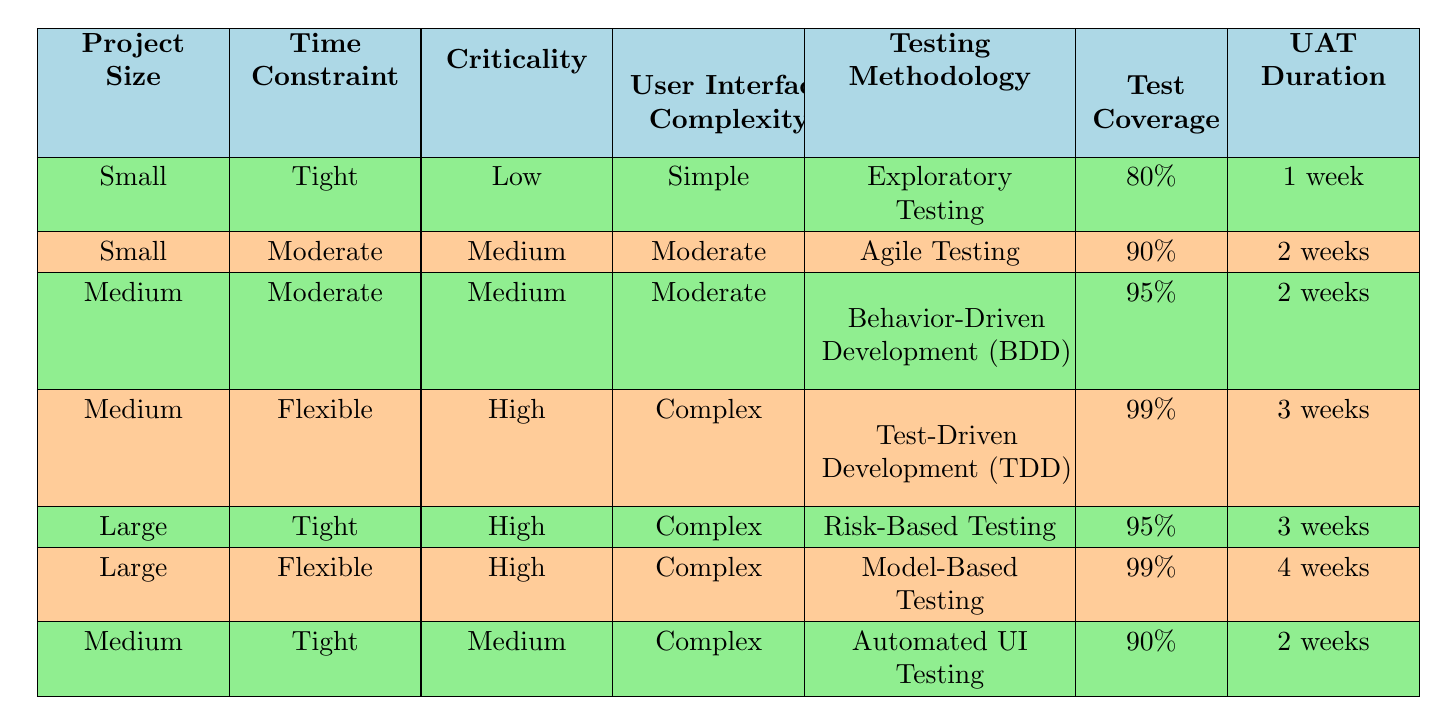What testing methodology is recommended for a small project with tight time constraints and low criticality? To find the answer, look for the row where Project Size is "Small", Time Constraint is "Tight", and Criticality is "Low". In the table, this matches the actions: "Exploratory Testing".
Answer: Exploratory Testing What is the test coverage for a medium project that has a moderate time constraint and medium criticality? Identify the row with Project Size as "Medium", Time Constraint as "Moderate", and Criticality as "Medium". This reveals the Test Coverage value listed as "95%".
Answer: 95% Are user acceptance testing durations consistent across all project types? Check each row in the table for User Acceptance Testing Duration. "1 week", "2 weeks", "3 weeks", and "4 weeks" are all present, indicating varying durations based on project types rather than consistency.
Answer: No What is the maximum test coverage achievable for projects with high criticality? Examine the rows where Criticality is "High". The maximum test coverage in these rows is "99%", which corresponds to both the Medium project with a flexible time constraint and the Large project with a flexible time constraint.
Answer: 99% For large projects with a tight time constraint and high criticality, how long is the user acceptance testing duration? Locate the row with Project Size "Large", Time Constraint "Tight", and Criticality "High". The table shows that the UAT Duration for this scenario is "3 weeks".
Answer: 3 weeks What is the ratio of user acceptance testing duration between small projects with tight constraints and large projects with flexible constraints? The small project has a UAT Duration of "1 week" and the large project has "4 weeks". The ratio is calculated by dividing 4 by 1, resulting in 4:1.
Answer: 4:1 Is "Automated UI Testing" applicable to projects with medium size and tight constraints? Check the row corresponding to Medium project and Tight time constraint. It is confirmed that the methodology listed for such projects is "Automated UI Testing".
Answer: Yes What testing methodologies are used for projects with complex user interface requirements? Look for entries where User Interface Complexity is "Complex". The methodologies listed are "Test-Driven Development", "Risk-Based Testing", and "Model-Based Testing".
Answer: Test-Driven Development, Risk-Based Testing, Model-Based Testing 